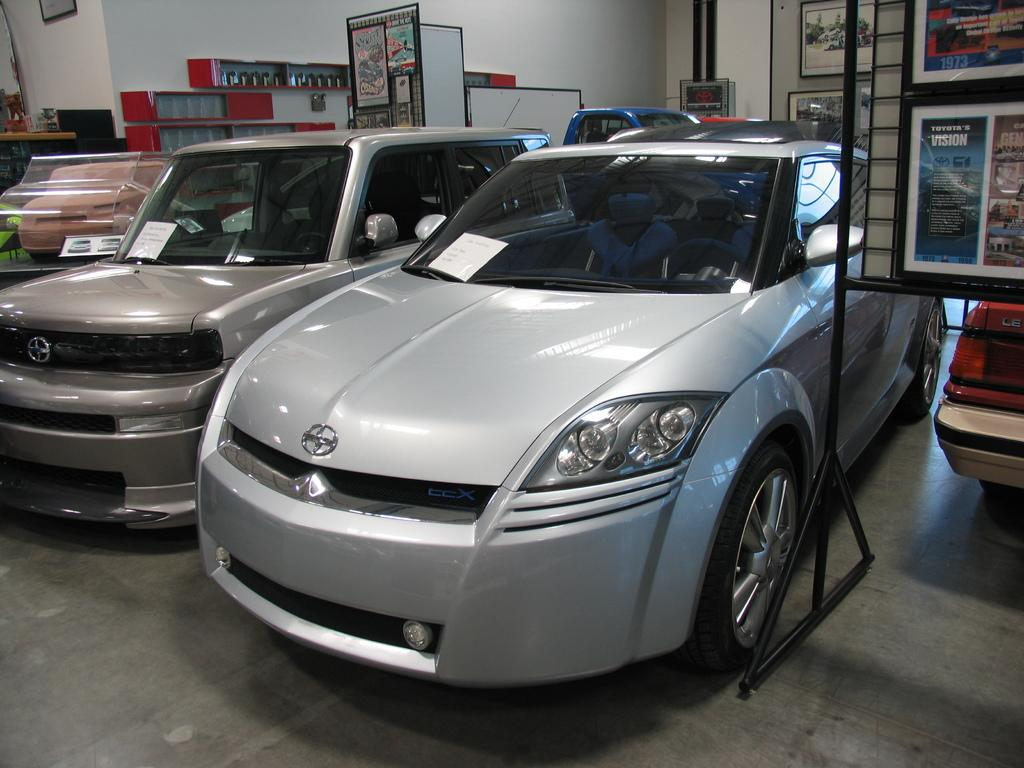What type of vehicles are inside the building in the image? There are cars in a building in the image. What can be seen on the walls of the building? There are boards, shelves, and a photo frame on the wall. What type of oil is being used to clean the crate in the image? There is no crate or oil present in the image. How does the photo frame burst in the image? The photo frame does not burst in the image; it is stationary on the wall. 